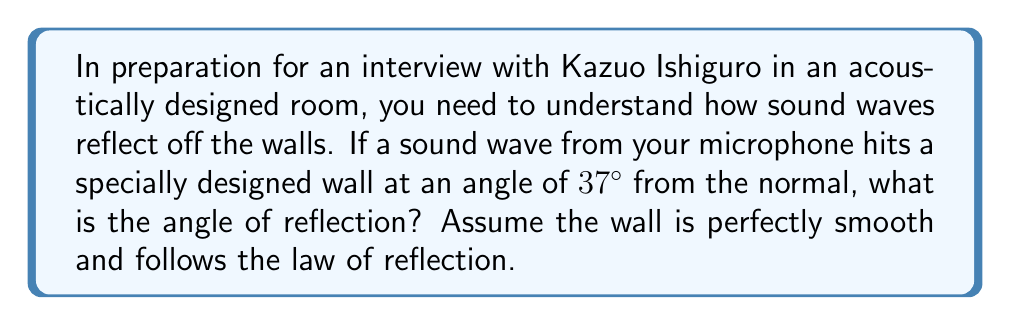Can you solve this math problem? To solve this problem, we need to apply the law of reflection, which states that the angle of incidence is equal to the angle of reflection. Here's a step-by-step explanation:

1. Understand the given information:
   - The incident angle is 37° from the normal.
   - The wall is perfectly smooth, so the law of reflection applies.

2. Recall the law of reflection:
   $$ \theta_i = \theta_r $$
   Where $\theta_i$ is the angle of incidence and $\theta_r$ is the angle of reflection.

3. In this case, we are given the angle of incidence:
   $$ \theta_i = 37° $$

4. Apply the law of reflection:
   $$ \theta_r = \theta_i = 37° $$

5. Therefore, the angle of reflection is also 37°.

[asy]
import geometry;

size(200);
defaultpen(fontsize(10pt));

pair O=(0,0), A=(5,0), B=(5,4);
draw(O--A--B--cycle);

label("Normal", (5,5), N);
label("Wall", (2.5,-0.5), S);
label("37°", (0.7,0.3), NW);
label("37°", (4.3,0.3), NE);

draw((-1,0)--(6,0), dashed);
draw((5,0)--(5,5), dashed);

draw(arc(O,0.7,0,37), Arrow);
draw(arc(A,0.7,180-37,180), Arrow);

label("Incident wave", (-0.5,1), NW);
label("Reflected wave", (5.5,1), NE);
[/asy]

This diagram illustrates the incident wave, reflected wave, and the angles involved.
Answer: The angle of reflection is 37°. 